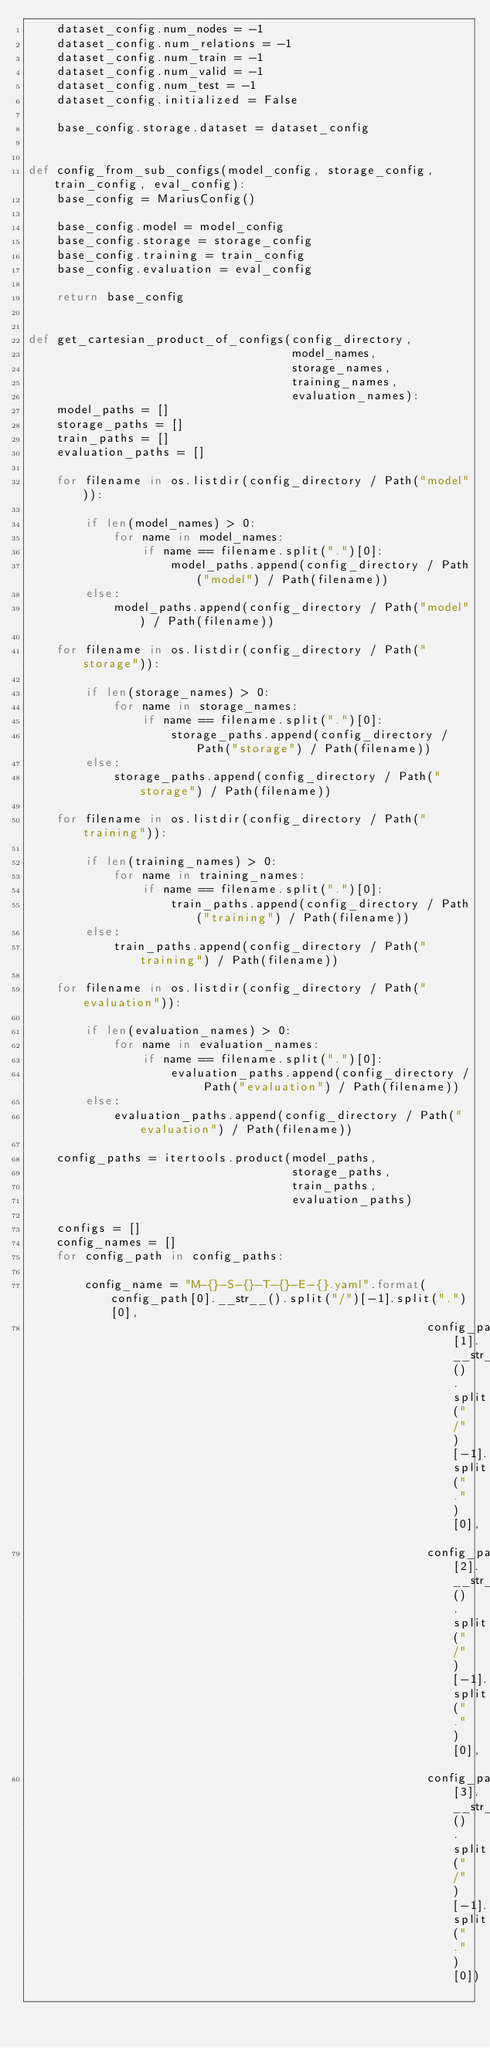Convert code to text. <code><loc_0><loc_0><loc_500><loc_500><_Python_>    dataset_config.num_nodes = -1
    dataset_config.num_relations = -1
    dataset_config.num_train = -1
    dataset_config.num_valid = -1
    dataset_config.num_test = -1
    dataset_config.initialized = False
    
    base_config.storage.dataset = dataset_config


def config_from_sub_configs(model_config, storage_config, train_config, eval_config):
    base_config = MariusConfig()

    base_config.model = model_config
    base_config.storage = storage_config
    base_config.training = train_config
    base_config.evaluation = eval_config

    return base_config


def get_cartesian_product_of_configs(config_directory,
                                     model_names,
                                     storage_names,
                                     training_names,
                                     evaluation_names):
    model_paths = []
    storage_paths = []
    train_paths = []
    evaluation_paths = []

    for filename in os.listdir(config_directory / Path("model")):

        if len(model_names) > 0:
            for name in model_names:
                if name == filename.split(".")[0]:
                    model_paths.append(config_directory / Path("model") / Path(filename))
        else:
            model_paths.append(config_directory / Path("model") / Path(filename))

    for filename in os.listdir(config_directory / Path("storage")):

        if len(storage_names) > 0:
            for name in storage_names:
                if name == filename.split(".")[0]:
                    storage_paths.append(config_directory / Path("storage") / Path(filename))
        else:
            storage_paths.append(config_directory / Path("storage") / Path(filename))

    for filename in os.listdir(config_directory / Path("training")):

        if len(training_names) > 0:
            for name in training_names:
                if name == filename.split(".")[0]:
                    train_paths.append(config_directory / Path("training") / Path(filename))
        else:
            train_paths.append(config_directory / Path("training") / Path(filename))

    for filename in os.listdir(config_directory / Path("evaluation")):

        if len(evaluation_names) > 0:
            for name in evaluation_names:
                if name == filename.split(".")[0]:
                    evaluation_paths.append(config_directory / Path("evaluation") / Path(filename))
        else:
            evaluation_paths.append(config_directory / Path("evaluation") / Path(filename))

    config_paths = itertools.product(model_paths,
                                     storage_paths,
                                     train_paths,
                                     evaluation_paths)

    configs = []
    config_names = []
    for config_path in config_paths:

        config_name = "M-{}-S-{}-T-{}-E-{}.yaml".format(config_path[0].__str__().split("/")[-1].split(".")[0],
                                                        config_path[1].__str__().split("/")[-1].split(".")[0],
                                                        config_path[2].__str__().split("/")[-1].split(".")[0],
                                                        config_path[3].__str__().split("/")[-1].split(".")[0])</code> 